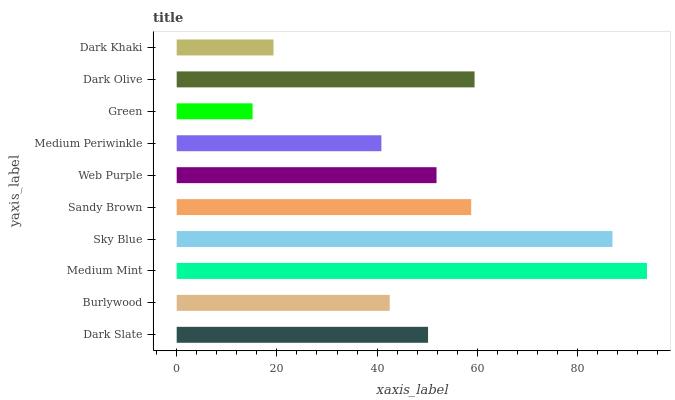Is Green the minimum?
Answer yes or no. Yes. Is Medium Mint the maximum?
Answer yes or no. Yes. Is Burlywood the minimum?
Answer yes or no. No. Is Burlywood the maximum?
Answer yes or no. No. Is Dark Slate greater than Burlywood?
Answer yes or no. Yes. Is Burlywood less than Dark Slate?
Answer yes or no. Yes. Is Burlywood greater than Dark Slate?
Answer yes or no. No. Is Dark Slate less than Burlywood?
Answer yes or no. No. Is Web Purple the high median?
Answer yes or no. Yes. Is Dark Slate the low median?
Answer yes or no. Yes. Is Dark Khaki the high median?
Answer yes or no. No. Is Medium Periwinkle the low median?
Answer yes or no. No. 